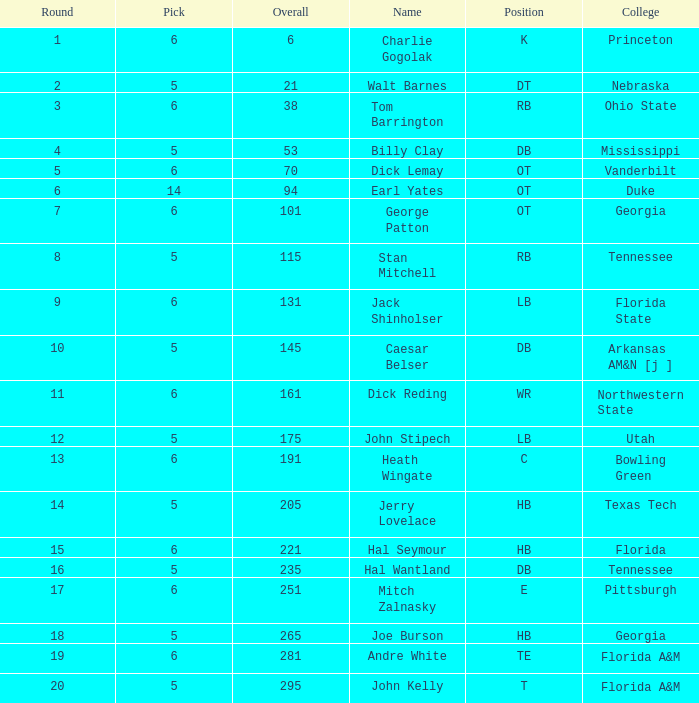What is Name, when Overall is less than 175, and when College is "Georgia"? George Patton. 